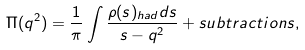<formula> <loc_0><loc_0><loc_500><loc_500>\Pi ( q ^ { 2 } ) = \frac { 1 } { \pi } \int \frac { \rho ( s ) _ { h a d } d s } { s - q ^ { 2 } } + s u b t r a c t i o n s ,</formula> 